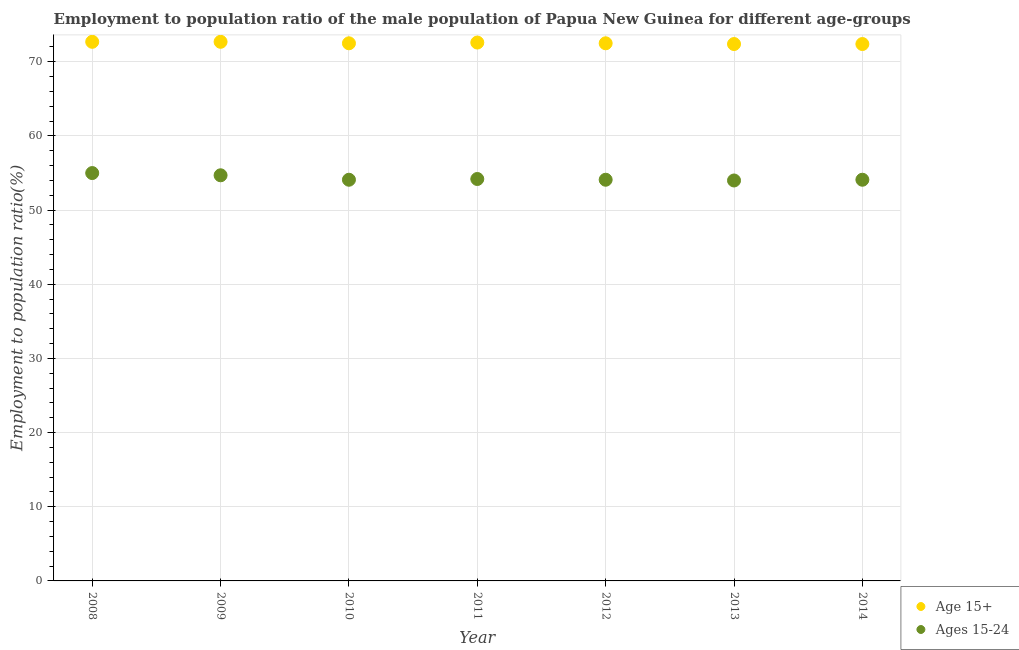How many different coloured dotlines are there?
Provide a short and direct response. 2. What is the employment to population ratio(age 15+) in 2009?
Make the answer very short. 72.7. Across all years, what is the minimum employment to population ratio(age 15+)?
Offer a terse response. 72.4. In which year was the employment to population ratio(age 15+) maximum?
Keep it short and to the point. 2008. What is the total employment to population ratio(age 15+) in the graph?
Keep it short and to the point. 507.8. What is the difference between the employment to population ratio(age 15-24) in 2011 and that in 2013?
Provide a succinct answer. 0.2. What is the difference between the employment to population ratio(age 15+) in 2012 and the employment to population ratio(age 15-24) in 2009?
Give a very brief answer. 17.8. What is the average employment to population ratio(age 15+) per year?
Offer a terse response. 72.54. In the year 2010, what is the difference between the employment to population ratio(age 15+) and employment to population ratio(age 15-24)?
Keep it short and to the point. 18.4. In how many years, is the employment to population ratio(age 15-24) greater than 58 %?
Offer a terse response. 0. What is the ratio of the employment to population ratio(age 15-24) in 2013 to that in 2014?
Your response must be concise. 1. Is the difference between the employment to population ratio(age 15+) in 2009 and 2013 greater than the difference between the employment to population ratio(age 15-24) in 2009 and 2013?
Provide a short and direct response. No. What is the difference between the highest and the second highest employment to population ratio(age 15+)?
Provide a succinct answer. 0. What is the difference between the highest and the lowest employment to population ratio(age 15+)?
Offer a very short reply. 0.3. Is the sum of the employment to population ratio(age 15-24) in 2008 and 2011 greater than the maximum employment to population ratio(age 15+) across all years?
Provide a short and direct response. Yes. Is the employment to population ratio(age 15-24) strictly greater than the employment to population ratio(age 15+) over the years?
Provide a short and direct response. No. Is the employment to population ratio(age 15-24) strictly less than the employment to population ratio(age 15+) over the years?
Your answer should be compact. Yes. How many dotlines are there?
Your answer should be very brief. 2. How many years are there in the graph?
Your answer should be very brief. 7. Does the graph contain any zero values?
Ensure brevity in your answer.  No. Does the graph contain grids?
Provide a short and direct response. Yes. How are the legend labels stacked?
Ensure brevity in your answer.  Vertical. What is the title of the graph?
Give a very brief answer. Employment to population ratio of the male population of Papua New Guinea for different age-groups. What is the label or title of the Y-axis?
Your answer should be very brief. Employment to population ratio(%). What is the Employment to population ratio(%) of Age 15+ in 2008?
Ensure brevity in your answer.  72.7. What is the Employment to population ratio(%) of Ages 15-24 in 2008?
Give a very brief answer. 55. What is the Employment to population ratio(%) of Age 15+ in 2009?
Give a very brief answer. 72.7. What is the Employment to population ratio(%) of Ages 15-24 in 2009?
Ensure brevity in your answer.  54.7. What is the Employment to population ratio(%) in Age 15+ in 2010?
Keep it short and to the point. 72.5. What is the Employment to population ratio(%) in Ages 15-24 in 2010?
Your answer should be compact. 54.1. What is the Employment to population ratio(%) of Age 15+ in 2011?
Keep it short and to the point. 72.6. What is the Employment to population ratio(%) in Ages 15-24 in 2011?
Provide a succinct answer. 54.2. What is the Employment to population ratio(%) in Age 15+ in 2012?
Make the answer very short. 72.5. What is the Employment to population ratio(%) in Ages 15-24 in 2012?
Ensure brevity in your answer.  54.1. What is the Employment to population ratio(%) in Age 15+ in 2013?
Your answer should be very brief. 72.4. What is the Employment to population ratio(%) of Ages 15-24 in 2013?
Your answer should be very brief. 54. What is the Employment to population ratio(%) in Age 15+ in 2014?
Provide a short and direct response. 72.4. What is the Employment to population ratio(%) of Ages 15-24 in 2014?
Offer a very short reply. 54.1. Across all years, what is the maximum Employment to population ratio(%) in Age 15+?
Give a very brief answer. 72.7. Across all years, what is the minimum Employment to population ratio(%) of Age 15+?
Keep it short and to the point. 72.4. Across all years, what is the minimum Employment to population ratio(%) in Ages 15-24?
Ensure brevity in your answer.  54. What is the total Employment to population ratio(%) in Age 15+ in the graph?
Offer a terse response. 507.8. What is the total Employment to population ratio(%) in Ages 15-24 in the graph?
Offer a very short reply. 380.2. What is the difference between the Employment to population ratio(%) in Age 15+ in 2008 and that in 2009?
Your answer should be very brief. 0. What is the difference between the Employment to population ratio(%) of Ages 15-24 in 2008 and that in 2009?
Your answer should be compact. 0.3. What is the difference between the Employment to population ratio(%) of Age 15+ in 2008 and that in 2010?
Your answer should be compact. 0.2. What is the difference between the Employment to population ratio(%) in Ages 15-24 in 2008 and that in 2010?
Give a very brief answer. 0.9. What is the difference between the Employment to population ratio(%) in Age 15+ in 2008 and that in 2011?
Offer a very short reply. 0.1. What is the difference between the Employment to population ratio(%) of Age 15+ in 2008 and that in 2012?
Give a very brief answer. 0.2. What is the difference between the Employment to population ratio(%) in Age 15+ in 2008 and that in 2013?
Keep it short and to the point. 0.3. What is the difference between the Employment to population ratio(%) in Ages 15-24 in 2008 and that in 2014?
Offer a terse response. 0.9. What is the difference between the Employment to population ratio(%) in Ages 15-24 in 2009 and that in 2010?
Ensure brevity in your answer.  0.6. What is the difference between the Employment to population ratio(%) in Age 15+ in 2009 and that in 2011?
Provide a succinct answer. 0.1. What is the difference between the Employment to population ratio(%) in Ages 15-24 in 2009 and that in 2011?
Provide a succinct answer. 0.5. What is the difference between the Employment to population ratio(%) of Age 15+ in 2009 and that in 2013?
Your answer should be compact. 0.3. What is the difference between the Employment to population ratio(%) in Age 15+ in 2010 and that in 2011?
Your answer should be compact. -0.1. What is the difference between the Employment to population ratio(%) of Ages 15-24 in 2010 and that in 2011?
Your answer should be very brief. -0.1. What is the difference between the Employment to population ratio(%) of Ages 15-24 in 2010 and that in 2012?
Offer a very short reply. 0. What is the difference between the Employment to population ratio(%) of Age 15+ in 2010 and that in 2014?
Give a very brief answer. 0.1. What is the difference between the Employment to population ratio(%) in Ages 15-24 in 2010 and that in 2014?
Offer a terse response. 0. What is the difference between the Employment to population ratio(%) in Ages 15-24 in 2011 and that in 2012?
Provide a succinct answer. 0.1. What is the difference between the Employment to population ratio(%) of Age 15+ in 2011 and that in 2013?
Your response must be concise. 0.2. What is the difference between the Employment to population ratio(%) in Ages 15-24 in 2011 and that in 2014?
Your answer should be compact. 0.1. What is the difference between the Employment to population ratio(%) in Ages 15-24 in 2012 and that in 2013?
Make the answer very short. 0.1. What is the difference between the Employment to population ratio(%) of Ages 15-24 in 2012 and that in 2014?
Your answer should be very brief. 0. What is the difference between the Employment to population ratio(%) of Age 15+ in 2013 and that in 2014?
Offer a terse response. 0. What is the difference between the Employment to population ratio(%) of Ages 15-24 in 2013 and that in 2014?
Give a very brief answer. -0.1. What is the difference between the Employment to population ratio(%) of Age 15+ in 2008 and the Employment to population ratio(%) of Ages 15-24 in 2009?
Your answer should be compact. 18. What is the difference between the Employment to population ratio(%) of Age 15+ in 2008 and the Employment to population ratio(%) of Ages 15-24 in 2010?
Your answer should be compact. 18.6. What is the difference between the Employment to population ratio(%) of Age 15+ in 2008 and the Employment to population ratio(%) of Ages 15-24 in 2011?
Offer a very short reply. 18.5. What is the difference between the Employment to population ratio(%) of Age 15+ in 2008 and the Employment to population ratio(%) of Ages 15-24 in 2013?
Your answer should be very brief. 18.7. What is the difference between the Employment to population ratio(%) of Age 15+ in 2009 and the Employment to population ratio(%) of Ages 15-24 in 2010?
Your answer should be compact. 18.6. What is the difference between the Employment to population ratio(%) in Age 15+ in 2009 and the Employment to population ratio(%) in Ages 15-24 in 2011?
Offer a very short reply. 18.5. What is the difference between the Employment to population ratio(%) of Age 15+ in 2010 and the Employment to population ratio(%) of Ages 15-24 in 2011?
Your answer should be compact. 18.3. What is the difference between the Employment to population ratio(%) of Age 15+ in 2010 and the Employment to population ratio(%) of Ages 15-24 in 2014?
Give a very brief answer. 18.4. What is the difference between the Employment to population ratio(%) of Age 15+ in 2011 and the Employment to population ratio(%) of Ages 15-24 in 2012?
Your response must be concise. 18.5. What is the difference between the Employment to population ratio(%) of Age 15+ in 2011 and the Employment to population ratio(%) of Ages 15-24 in 2014?
Keep it short and to the point. 18.5. What is the difference between the Employment to population ratio(%) in Age 15+ in 2012 and the Employment to population ratio(%) in Ages 15-24 in 2014?
Offer a terse response. 18.4. What is the difference between the Employment to population ratio(%) of Age 15+ in 2013 and the Employment to population ratio(%) of Ages 15-24 in 2014?
Your answer should be very brief. 18.3. What is the average Employment to population ratio(%) in Age 15+ per year?
Keep it short and to the point. 72.54. What is the average Employment to population ratio(%) in Ages 15-24 per year?
Keep it short and to the point. 54.31. In the year 2011, what is the difference between the Employment to population ratio(%) of Age 15+ and Employment to population ratio(%) of Ages 15-24?
Your response must be concise. 18.4. In the year 2014, what is the difference between the Employment to population ratio(%) of Age 15+ and Employment to population ratio(%) of Ages 15-24?
Your response must be concise. 18.3. What is the ratio of the Employment to population ratio(%) in Age 15+ in 2008 to that in 2009?
Offer a terse response. 1. What is the ratio of the Employment to population ratio(%) in Age 15+ in 2008 to that in 2010?
Ensure brevity in your answer.  1. What is the ratio of the Employment to population ratio(%) of Ages 15-24 in 2008 to that in 2010?
Make the answer very short. 1.02. What is the ratio of the Employment to population ratio(%) in Age 15+ in 2008 to that in 2011?
Offer a very short reply. 1. What is the ratio of the Employment to population ratio(%) in Ages 15-24 in 2008 to that in 2011?
Keep it short and to the point. 1.01. What is the ratio of the Employment to population ratio(%) in Ages 15-24 in 2008 to that in 2012?
Offer a terse response. 1.02. What is the ratio of the Employment to population ratio(%) of Age 15+ in 2008 to that in 2013?
Ensure brevity in your answer.  1. What is the ratio of the Employment to population ratio(%) of Ages 15-24 in 2008 to that in 2013?
Keep it short and to the point. 1.02. What is the ratio of the Employment to population ratio(%) in Ages 15-24 in 2008 to that in 2014?
Your response must be concise. 1.02. What is the ratio of the Employment to population ratio(%) in Age 15+ in 2009 to that in 2010?
Provide a succinct answer. 1. What is the ratio of the Employment to population ratio(%) in Ages 15-24 in 2009 to that in 2010?
Your response must be concise. 1.01. What is the ratio of the Employment to population ratio(%) of Age 15+ in 2009 to that in 2011?
Provide a short and direct response. 1. What is the ratio of the Employment to population ratio(%) of Ages 15-24 in 2009 to that in 2011?
Your answer should be very brief. 1.01. What is the ratio of the Employment to population ratio(%) in Ages 15-24 in 2009 to that in 2012?
Provide a succinct answer. 1.01. What is the ratio of the Employment to population ratio(%) of Age 15+ in 2009 to that in 2013?
Provide a succinct answer. 1. What is the ratio of the Employment to population ratio(%) in Age 15+ in 2009 to that in 2014?
Your response must be concise. 1. What is the ratio of the Employment to population ratio(%) in Ages 15-24 in 2009 to that in 2014?
Offer a very short reply. 1.01. What is the ratio of the Employment to population ratio(%) in Ages 15-24 in 2010 to that in 2011?
Your response must be concise. 1. What is the ratio of the Employment to population ratio(%) in Age 15+ in 2010 to that in 2012?
Give a very brief answer. 1. What is the ratio of the Employment to population ratio(%) in Ages 15-24 in 2010 to that in 2013?
Your answer should be very brief. 1. What is the ratio of the Employment to population ratio(%) in Age 15+ in 2010 to that in 2014?
Make the answer very short. 1. What is the ratio of the Employment to population ratio(%) of Ages 15-24 in 2010 to that in 2014?
Give a very brief answer. 1. What is the ratio of the Employment to population ratio(%) of Age 15+ in 2011 to that in 2012?
Offer a very short reply. 1. What is the ratio of the Employment to population ratio(%) in Ages 15-24 in 2011 to that in 2012?
Your response must be concise. 1. What is the ratio of the Employment to population ratio(%) in Ages 15-24 in 2011 to that in 2013?
Your response must be concise. 1. What is the ratio of the Employment to population ratio(%) in Age 15+ in 2011 to that in 2014?
Provide a succinct answer. 1. What is the ratio of the Employment to population ratio(%) in Age 15+ in 2012 to that in 2013?
Your response must be concise. 1. What is the ratio of the Employment to population ratio(%) of Ages 15-24 in 2012 to that in 2013?
Offer a terse response. 1. What is the ratio of the Employment to population ratio(%) of Age 15+ in 2012 to that in 2014?
Make the answer very short. 1. What is the ratio of the Employment to population ratio(%) in Ages 15-24 in 2013 to that in 2014?
Give a very brief answer. 1. What is the difference between the highest and the second highest Employment to population ratio(%) of Ages 15-24?
Provide a short and direct response. 0.3. 